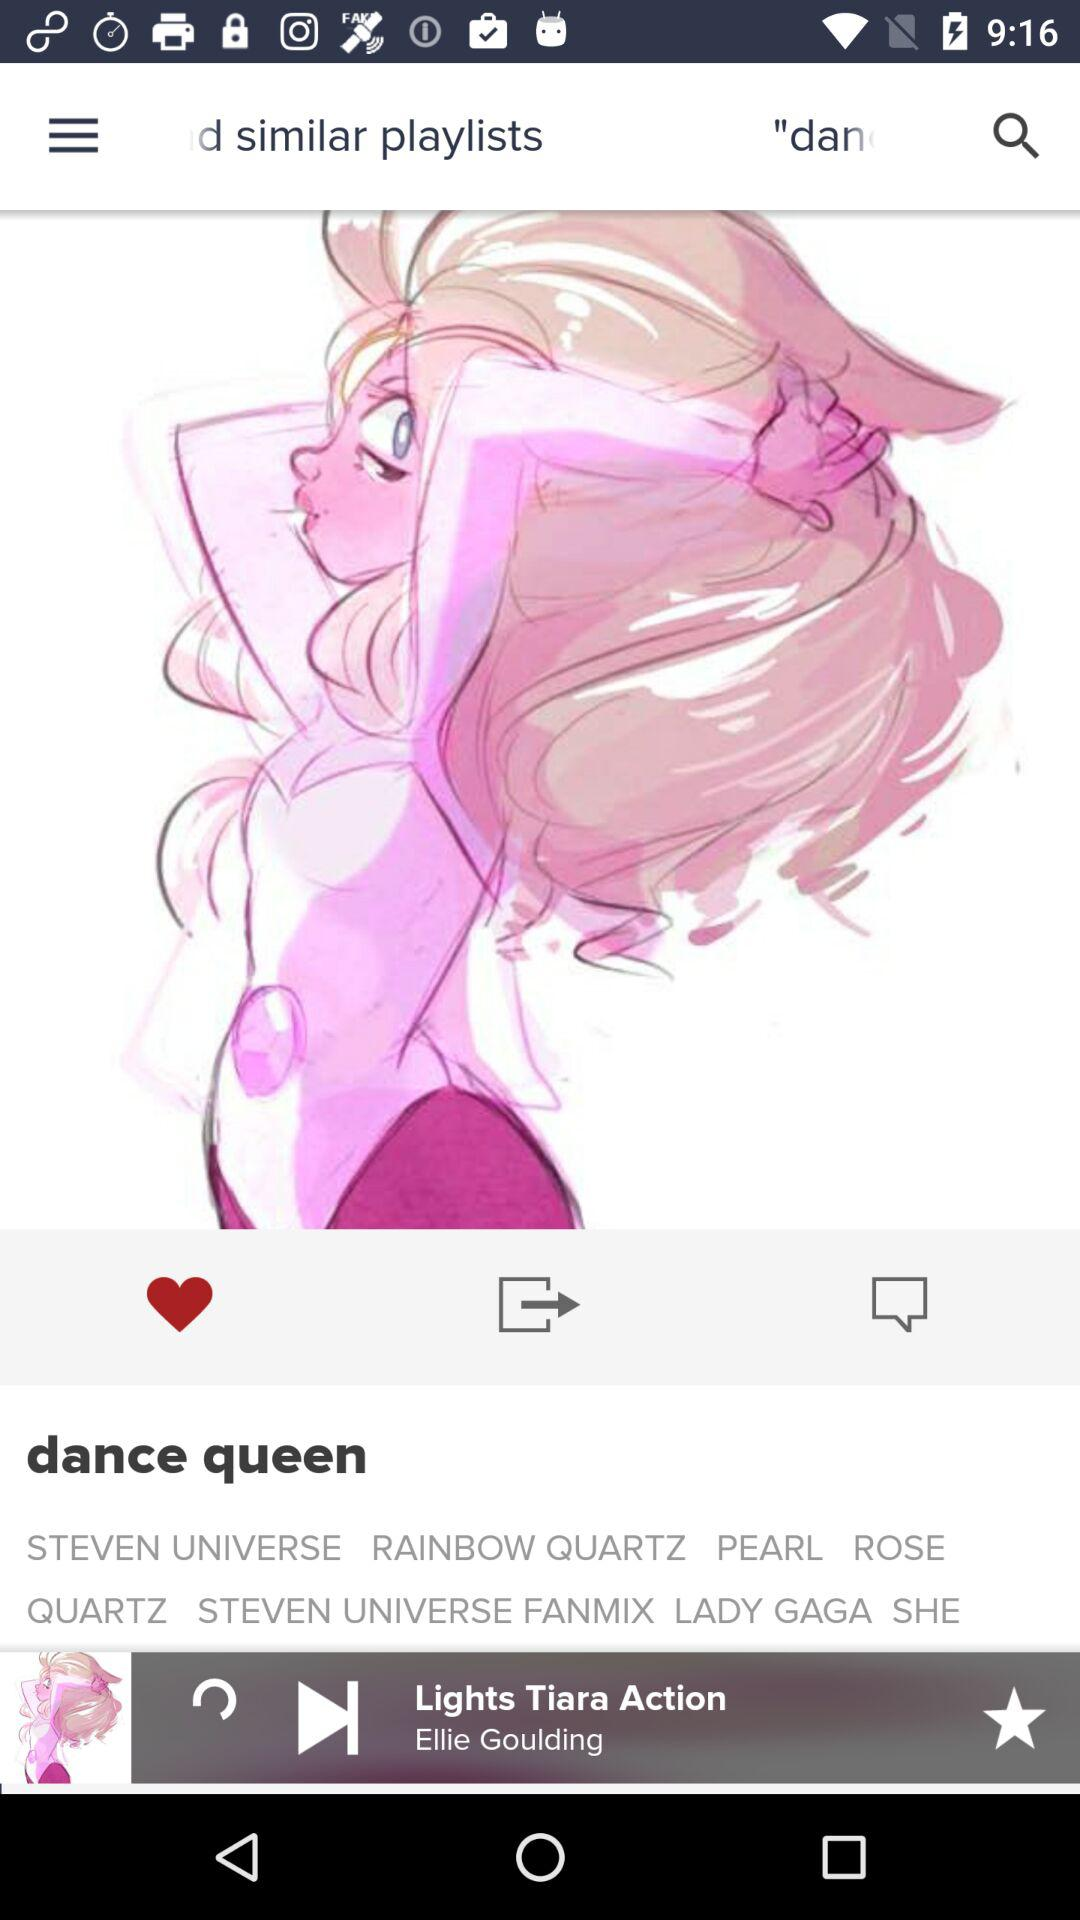Who is the singer of the "Lights Tiara Action" song? The singer of the "Lights Tiara Action" song is Ellie Goulding. 